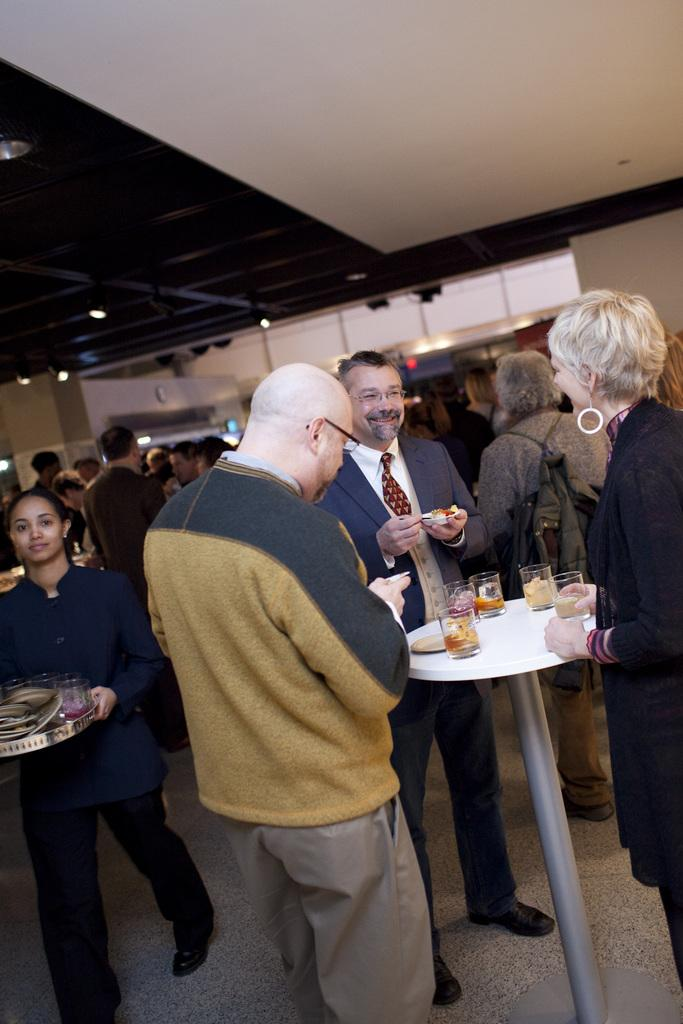Who or what is present in the image? There are people in the image. What objects can be seen on the table? There are glasses and a plate on the table. What can be seen in the background of the image? There are lights and a wall visible in the background of the image. What color is the brain in the image? There is no brain present in the image. What industry is depicted in the image? The image does not depict any specific industry. 